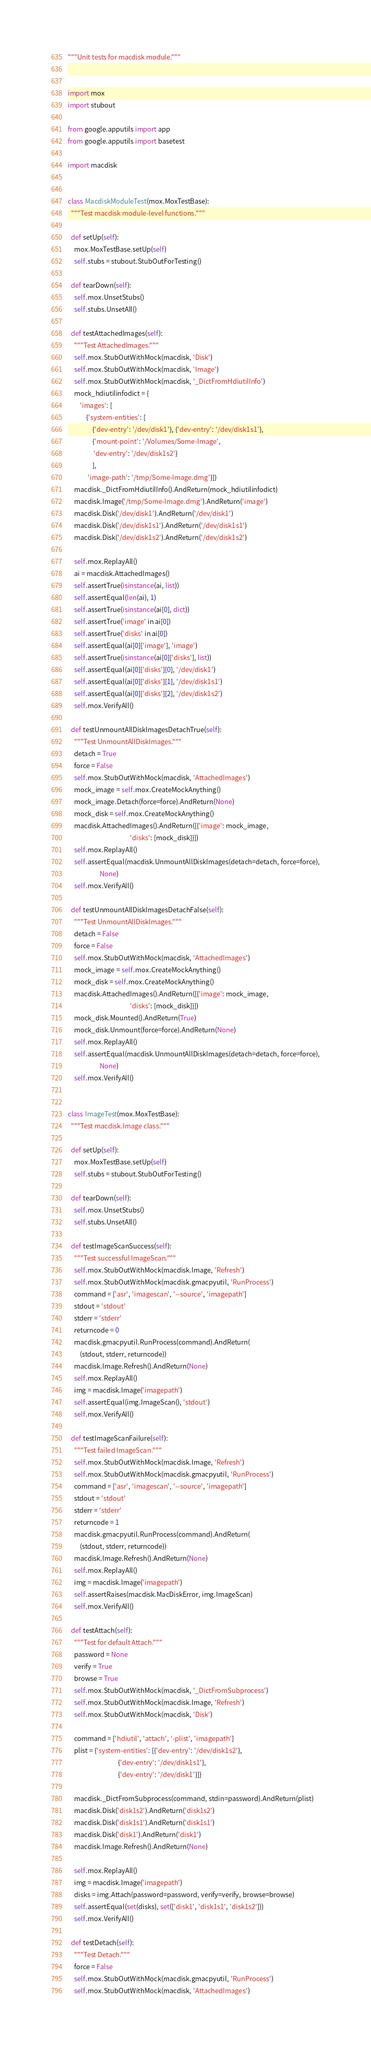Convert code to text. <code><loc_0><loc_0><loc_500><loc_500><_Python_>"""Unit tests for macdisk module."""


import mox
import stubout

from google.apputils import app
from google.apputils import basetest

import macdisk


class MacdiskModuleTest(mox.MoxTestBase):
  """Test macdisk module-level functions."""

  def setUp(self):
    mox.MoxTestBase.setUp(self)
    self.stubs = stubout.StubOutForTesting()

  def tearDown(self):
    self.mox.UnsetStubs()
    self.stubs.UnsetAll()

  def testAttachedImages(self):
    """Test AttachedImages."""
    self.mox.StubOutWithMock(macdisk, 'Disk')
    self.mox.StubOutWithMock(macdisk, 'Image')
    self.mox.StubOutWithMock(macdisk, '_DictFromHdiutilInfo')
    mock_hdiutilinfodict = {
        'images': [
            {'system-entities': [
                {'dev-entry': '/dev/disk1'}, {'dev-entry': '/dev/disk1s1'},
                {'mount-point': '/Volumes/Some-Image',
                 'dev-entry': '/dev/disk1s2'}
                ],
             'image-path': '/tmp/Some-Image.dmg'}]}
    macdisk._DictFromHdiutilInfo().AndReturn(mock_hdiutilinfodict)
    macdisk.Image('/tmp/Some-Image.dmg').AndReturn('image')
    macdisk.Disk('/dev/disk1').AndReturn('/dev/disk1')
    macdisk.Disk('/dev/disk1s1').AndReturn('/dev/disk1s1')
    macdisk.Disk('/dev/disk1s2').AndReturn('/dev/disk1s2')

    self.mox.ReplayAll()
    ai = macdisk.AttachedImages()
    self.assertTrue(isinstance(ai, list))
    self.assertEqual(len(ai), 1)
    self.assertTrue(isinstance(ai[0], dict))
    self.assertTrue('image' in ai[0])
    self.assertTrue('disks' in ai[0])
    self.assertEqual(ai[0]['image'], 'image')
    self.assertTrue(isinstance(ai[0]['disks'], list))
    self.assertEqual(ai[0]['disks'][0], '/dev/disk1')
    self.assertEqual(ai[0]['disks'][1], '/dev/disk1s1')
    self.assertEqual(ai[0]['disks'][2], '/dev/disk1s2')
    self.mox.VerifyAll()

  def testUnmountAllDiskImagesDetachTrue(self):
    """Test UnmountAllDiskImages."""
    detach = True
    force = False
    self.mox.StubOutWithMock(macdisk, 'AttachedImages')
    mock_image = self.mox.CreateMockAnything()
    mock_image.Detach(force=force).AndReturn(None)
    mock_disk = self.mox.CreateMockAnything()
    macdisk.AttachedImages().AndReturn([{'image': mock_image,
                                         'disks': [mock_disk]}])
    self.mox.ReplayAll()
    self.assertEqual(macdisk.UnmountAllDiskImages(detach=detach, force=force),
                     None)
    self.mox.VerifyAll()

  def testUnmountAllDiskImagesDetachFalse(self):
    """Test UnmountAllDiskImages."""
    detach = False
    force = False
    self.mox.StubOutWithMock(macdisk, 'AttachedImages')
    mock_image = self.mox.CreateMockAnything()
    mock_disk = self.mox.CreateMockAnything()
    macdisk.AttachedImages().AndReturn([{'image': mock_image,
                                         'disks': [mock_disk]}])
    mock_disk.Mounted().AndReturn(True)
    mock_disk.Unmount(force=force).AndReturn(None)
    self.mox.ReplayAll()
    self.assertEqual(macdisk.UnmountAllDiskImages(detach=detach, force=force),
                     None)
    self.mox.VerifyAll()


class ImageTest(mox.MoxTestBase):
  """Test macdisk.Image class."""

  def setUp(self):
    mox.MoxTestBase.setUp(self)
    self.stubs = stubout.StubOutForTesting()

  def tearDown(self):
    self.mox.UnsetStubs()
    self.stubs.UnsetAll()

  def testImageScanSuccess(self):
    """Test successful ImageScan."""
    self.mox.StubOutWithMock(macdisk.Image, 'Refresh')
    self.mox.StubOutWithMock(macdisk.gmacpyutil, 'RunProcess')
    command = ['asr', 'imagescan', '--source', 'imagepath']
    stdout = 'stdout'
    stderr = 'stderr'
    returncode = 0
    macdisk.gmacpyutil.RunProcess(command).AndReturn(
        (stdout, stderr, returncode))
    macdisk.Image.Refresh().AndReturn(None)
    self.mox.ReplayAll()
    img = macdisk.Image('imagepath')
    self.assertEqual(img.ImageScan(), 'stdout')
    self.mox.VerifyAll()

  def testImageScanFailure(self):
    """Test failed ImageScan."""
    self.mox.StubOutWithMock(macdisk.Image, 'Refresh')
    self.mox.StubOutWithMock(macdisk.gmacpyutil, 'RunProcess')
    command = ['asr', 'imagescan', '--source', 'imagepath']
    stdout = 'stdout'
    stderr = 'stderr'
    returncode = 1
    macdisk.gmacpyutil.RunProcess(command).AndReturn(
        (stdout, stderr, returncode))
    macdisk.Image.Refresh().AndReturn(None)
    self.mox.ReplayAll()
    img = macdisk.Image('imagepath')
    self.assertRaises(macdisk.MacDiskError, img.ImageScan)
    self.mox.VerifyAll()

  def testAttach(self):
    """Test for default Attach."""
    password = None
    verify = True
    browse = True
    self.mox.StubOutWithMock(macdisk, '_DictFromSubprocess')
    self.mox.StubOutWithMock(macdisk.Image, 'Refresh')
    self.mox.StubOutWithMock(macdisk, 'Disk')

    command = ['hdiutil', 'attach', '-plist', 'imagepath']
    plist = {'system-entities': [{'dev-entry': '/dev/disk1s2'},
                                 {'dev-entry': '/dev/disk1s1'},
                                 {'dev-entry': '/dev/disk1'}]}

    macdisk._DictFromSubprocess(command, stdin=password).AndReturn(plist)
    macdisk.Disk('disk1s2').AndReturn('disk1s2')
    macdisk.Disk('disk1s1').AndReturn('disk1s1')
    macdisk.Disk('disk1').AndReturn('disk1')
    macdisk.Image.Refresh().AndReturn(None)

    self.mox.ReplayAll()
    img = macdisk.Image('imagepath')
    disks = img.Attach(password=password, verify=verify, browse=browse)
    self.assertEqual(set(disks), set(['disk1', 'disk1s1', 'disk1s2']))
    self.mox.VerifyAll()

  def testDetach(self):
    """Test Detach."""
    force = False
    self.mox.StubOutWithMock(macdisk.gmacpyutil, 'RunProcess')
    self.mox.StubOutWithMock(macdisk, 'AttachedImages')</code> 